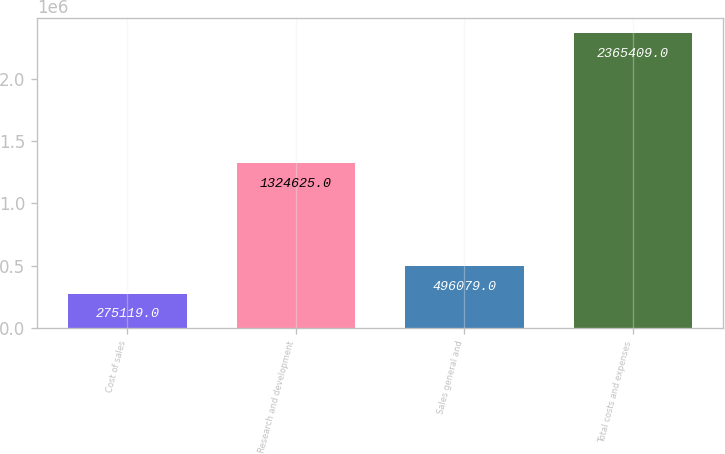Convert chart to OTSL. <chart><loc_0><loc_0><loc_500><loc_500><bar_chart><fcel>Cost of sales<fcel>Research and development<fcel>Sales general and<fcel>Total costs and expenses<nl><fcel>275119<fcel>1.32462e+06<fcel>496079<fcel>2.36541e+06<nl></chart> 